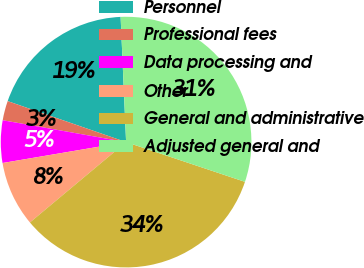<chart> <loc_0><loc_0><loc_500><loc_500><pie_chart><fcel>Personnel<fcel>Professional fees<fcel>Data processing and<fcel>Other<fcel>General and administrative<fcel>Adjusted general and<nl><fcel>19.0%<fcel>2.51%<fcel>5.46%<fcel>8.41%<fcel>33.78%<fcel>30.83%<nl></chart> 